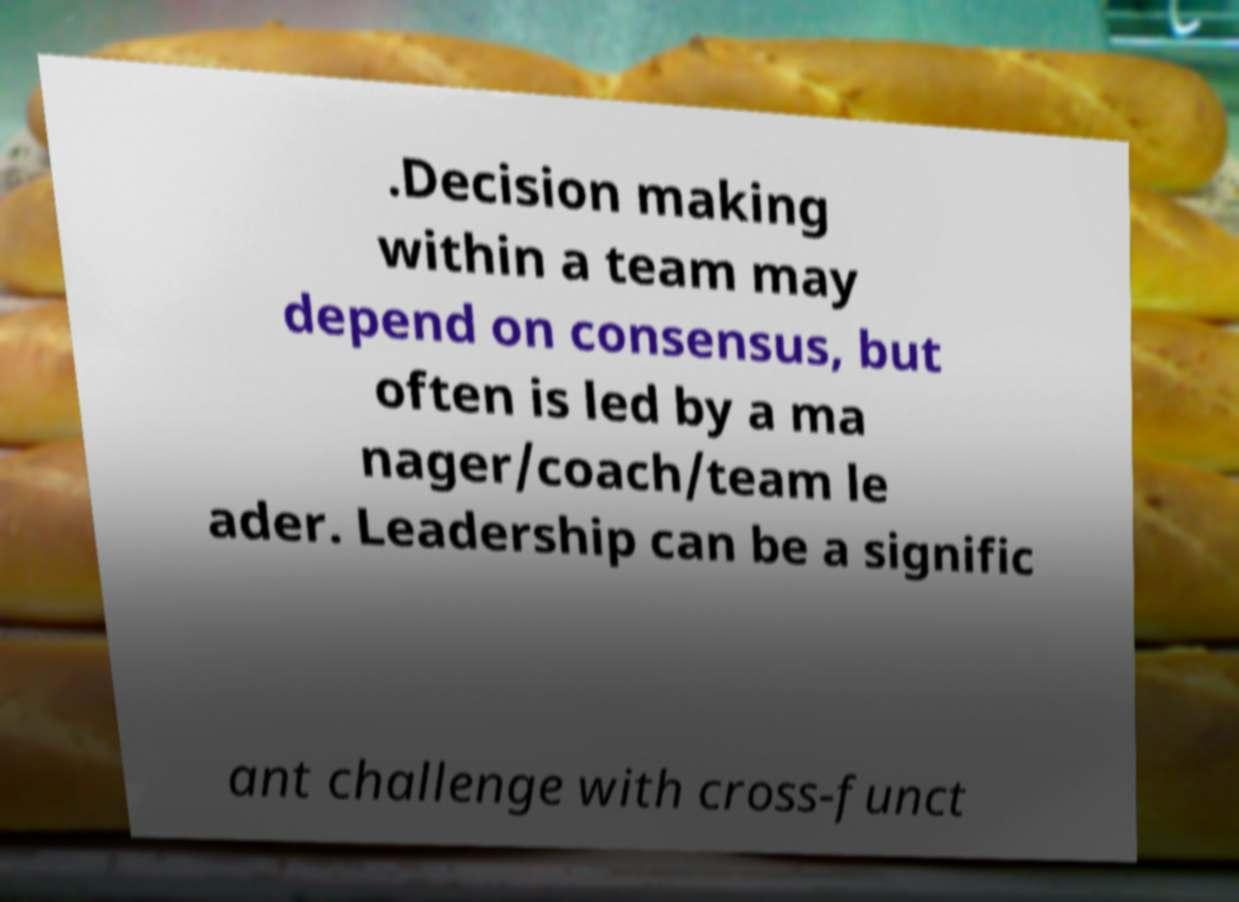Could you extract and type out the text from this image? .Decision making within a team may depend on consensus, but often is led by a ma nager/coach/team le ader. Leadership can be a signific ant challenge with cross-funct 